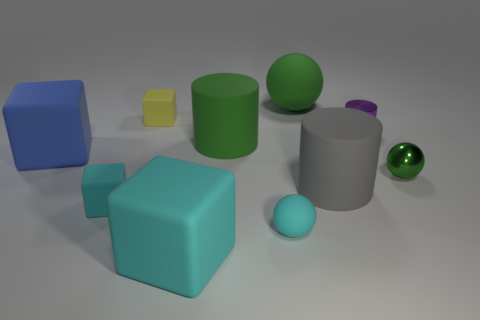Subtract 1 cubes. How many cubes are left? 3 Subtract all spheres. How many objects are left? 7 Add 5 cylinders. How many cylinders are left? 8 Add 8 large gray matte cylinders. How many large gray matte cylinders exist? 9 Subtract 0 yellow cylinders. How many objects are left? 10 Subtract all large things. Subtract all cyan balls. How many objects are left? 4 